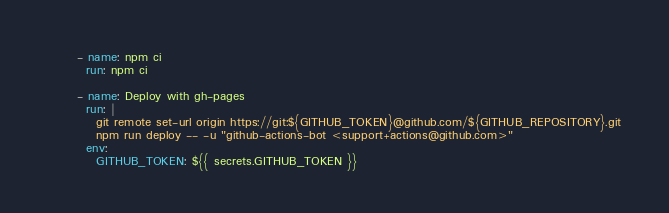<code> <loc_0><loc_0><loc_500><loc_500><_YAML_>      - name: npm ci
        run: npm ci

      - name: Deploy with gh-pages
        run: |
          git remote set-url origin https://git:${GITHUB_TOKEN}@github.com/${GITHUB_REPOSITORY}.git
          npm run deploy -- -u "github-actions-bot <support+actions@github.com>"
        env:
          GITHUB_TOKEN: ${{ secrets.GITHUB_TOKEN }}
</code> 